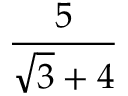<formula> <loc_0><loc_0><loc_500><loc_500>\frac { 5 } { { \sqrt { 3 } } + 4 }</formula> 